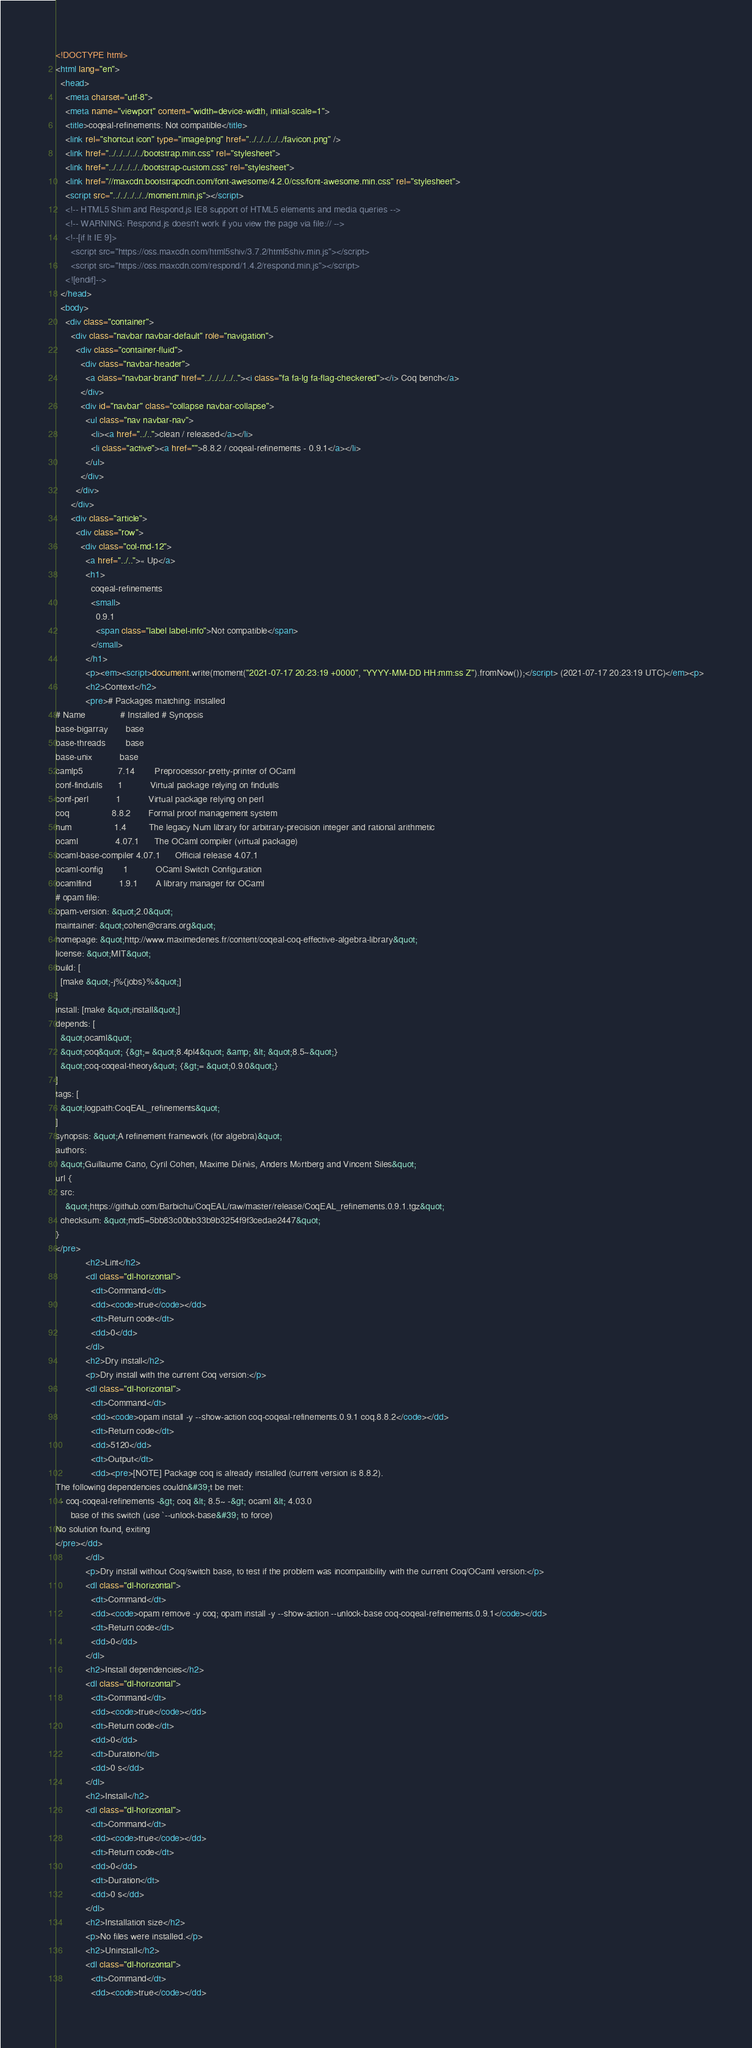Convert code to text. <code><loc_0><loc_0><loc_500><loc_500><_HTML_><!DOCTYPE html>
<html lang="en">
  <head>
    <meta charset="utf-8">
    <meta name="viewport" content="width=device-width, initial-scale=1">
    <title>coqeal-refinements: Not compatible</title>
    <link rel="shortcut icon" type="image/png" href="../../../../../favicon.png" />
    <link href="../../../../../bootstrap.min.css" rel="stylesheet">
    <link href="../../../../../bootstrap-custom.css" rel="stylesheet">
    <link href="//maxcdn.bootstrapcdn.com/font-awesome/4.2.0/css/font-awesome.min.css" rel="stylesheet">
    <script src="../../../../../moment.min.js"></script>
    <!-- HTML5 Shim and Respond.js IE8 support of HTML5 elements and media queries -->
    <!-- WARNING: Respond.js doesn't work if you view the page via file:// -->
    <!--[if lt IE 9]>
      <script src="https://oss.maxcdn.com/html5shiv/3.7.2/html5shiv.min.js"></script>
      <script src="https://oss.maxcdn.com/respond/1.4.2/respond.min.js"></script>
    <![endif]-->
  </head>
  <body>
    <div class="container">
      <div class="navbar navbar-default" role="navigation">
        <div class="container-fluid">
          <div class="navbar-header">
            <a class="navbar-brand" href="../../../../.."><i class="fa fa-lg fa-flag-checkered"></i> Coq bench</a>
          </div>
          <div id="navbar" class="collapse navbar-collapse">
            <ul class="nav navbar-nav">
              <li><a href="../..">clean / released</a></li>
              <li class="active"><a href="">8.8.2 / coqeal-refinements - 0.9.1</a></li>
            </ul>
          </div>
        </div>
      </div>
      <div class="article">
        <div class="row">
          <div class="col-md-12">
            <a href="../..">« Up</a>
            <h1>
              coqeal-refinements
              <small>
                0.9.1
                <span class="label label-info">Not compatible</span>
              </small>
            </h1>
            <p><em><script>document.write(moment("2021-07-17 20:23:19 +0000", "YYYY-MM-DD HH:mm:ss Z").fromNow());</script> (2021-07-17 20:23:19 UTC)</em><p>
            <h2>Context</h2>
            <pre># Packages matching: installed
# Name              # Installed # Synopsis
base-bigarray       base
base-threads        base
base-unix           base
camlp5              7.14        Preprocessor-pretty-printer of OCaml
conf-findutils      1           Virtual package relying on findutils
conf-perl           1           Virtual package relying on perl
coq                 8.8.2       Formal proof management system
num                 1.4         The legacy Num library for arbitrary-precision integer and rational arithmetic
ocaml               4.07.1      The OCaml compiler (virtual package)
ocaml-base-compiler 4.07.1      Official release 4.07.1
ocaml-config        1           OCaml Switch Configuration
ocamlfind           1.9.1       A library manager for OCaml
# opam file:
opam-version: &quot;2.0&quot;
maintainer: &quot;cohen@crans.org&quot;
homepage: &quot;http://www.maximedenes.fr/content/coqeal-coq-effective-algebra-library&quot;
license: &quot;MIT&quot;
build: [
  [make &quot;-j%{jobs}%&quot;]
]
install: [make &quot;install&quot;]
depends: [
  &quot;ocaml&quot;
  &quot;coq&quot; {&gt;= &quot;8.4pl4&quot; &amp; &lt; &quot;8.5~&quot;}
  &quot;coq-coqeal-theory&quot; {&gt;= &quot;0.9.0&quot;}
]
tags: [
  &quot;logpath:CoqEAL_refinements&quot;
]
synopsis: &quot;A refinement framework (for algebra)&quot;
authors:
  &quot;Guillaume Cano, Cyril Cohen, Maxime Dénès, Anders Mörtberg and Vincent Siles&quot;
url {
  src:
    &quot;https://github.com/Barbichu/CoqEAL/raw/master/release/CoqEAL_refinements.0.9.1.tgz&quot;
  checksum: &quot;md5=5bb83c00bb33b9b3254f9f3cedae2447&quot;
}
</pre>
            <h2>Lint</h2>
            <dl class="dl-horizontal">
              <dt>Command</dt>
              <dd><code>true</code></dd>
              <dt>Return code</dt>
              <dd>0</dd>
            </dl>
            <h2>Dry install</h2>
            <p>Dry install with the current Coq version:</p>
            <dl class="dl-horizontal">
              <dt>Command</dt>
              <dd><code>opam install -y --show-action coq-coqeal-refinements.0.9.1 coq.8.8.2</code></dd>
              <dt>Return code</dt>
              <dd>5120</dd>
              <dt>Output</dt>
              <dd><pre>[NOTE] Package coq is already installed (current version is 8.8.2).
The following dependencies couldn&#39;t be met:
  - coq-coqeal-refinements -&gt; coq &lt; 8.5~ -&gt; ocaml &lt; 4.03.0
      base of this switch (use `--unlock-base&#39; to force)
No solution found, exiting
</pre></dd>
            </dl>
            <p>Dry install without Coq/switch base, to test if the problem was incompatibility with the current Coq/OCaml version:</p>
            <dl class="dl-horizontal">
              <dt>Command</dt>
              <dd><code>opam remove -y coq; opam install -y --show-action --unlock-base coq-coqeal-refinements.0.9.1</code></dd>
              <dt>Return code</dt>
              <dd>0</dd>
            </dl>
            <h2>Install dependencies</h2>
            <dl class="dl-horizontal">
              <dt>Command</dt>
              <dd><code>true</code></dd>
              <dt>Return code</dt>
              <dd>0</dd>
              <dt>Duration</dt>
              <dd>0 s</dd>
            </dl>
            <h2>Install</h2>
            <dl class="dl-horizontal">
              <dt>Command</dt>
              <dd><code>true</code></dd>
              <dt>Return code</dt>
              <dd>0</dd>
              <dt>Duration</dt>
              <dd>0 s</dd>
            </dl>
            <h2>Installation size</h2>
            <p>No files were installed.</p>
            <h2>Uninstall</h2>
            <dl class="dl-horizontal">
              <dt>Command</dt>
              <dd><code>true</code></dd></code> 